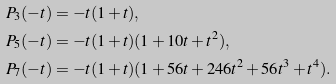Convert formula to latex. <formula><loc_0><loc_0><loc_500><loc_500>& P _ { 3 } ( - t ) = - t ( 1 + t ) , \\ & P _ { 5 } ( - t ) = - t ( 1 + t ) ( 1 + 1 0 t + t ^ { 2 } ) , \\ & P _ { 7 } ( - t ) = - t ( 1 + t ) ( 1 + 5 6 t + 2 4 6 t ^ { 2 } + 5 6 t ^ { 3 } + t ^ { 4 } ) .</formula> 